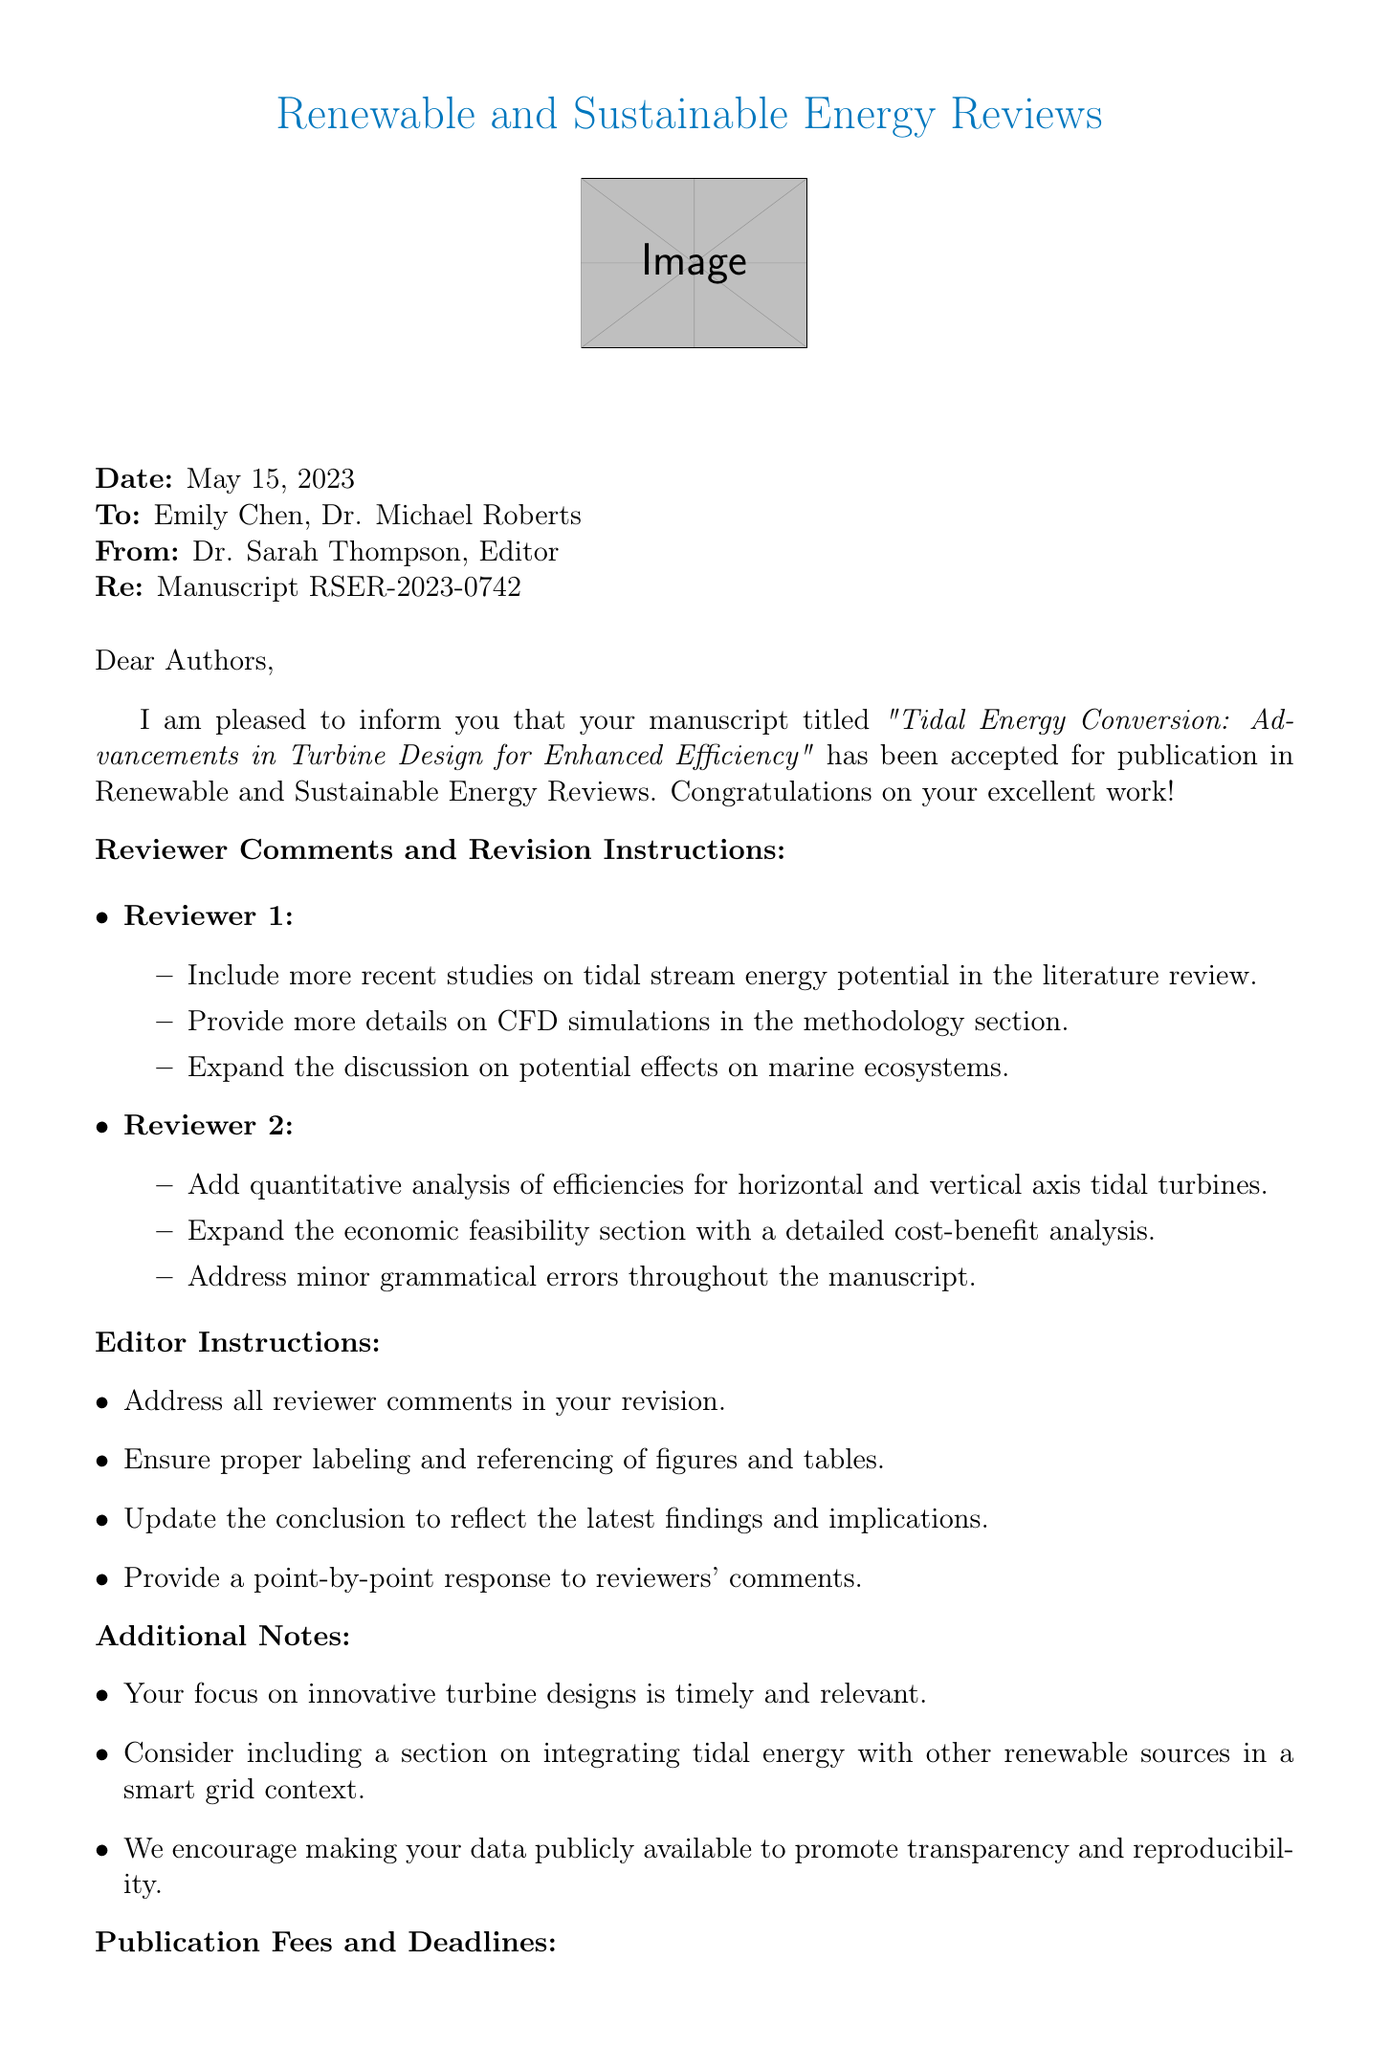What is the journal name? The journal name is stated at the beginning of the document.
Answer: Renewable and Sustainable Energy Reviews Who is the editor of the manuscript? The editor's name is mentioned in the "From" section of the document.
Answer: Dr. Sarah Thompson What is the manuscript number? The manuscript number is provided to identify the specific submission.
Answer: RSER-2023-0742 What is the acceptance date of the paper? The acceptance date is clearly listed in the document.
Answer: May 15, 2023 What is the revision deadline for the manuscript? The revision deadline is specified to guide authors on submission timing.
Answer: June 30, 2023 How much is the publication fee? The publication fee is explicitly stated within the document.
Answer: $1,500 USD What is one of the reviewer comments regarding methodology? The reviewer comments are summarized in specific sections of the document.
Answer: Provide more details on CFD simulations in the methodology section What should authors include in their cover letter? The final submission guidelines indicate what to include in the cover letter.
Answer: Detailing responses to reviewer comments What type of analysis do the reviewers suggest for the economic feasibility section? The document outlines suggestions from reviewers for content improvement.
Answer: A detailed cost-benefit analysis 